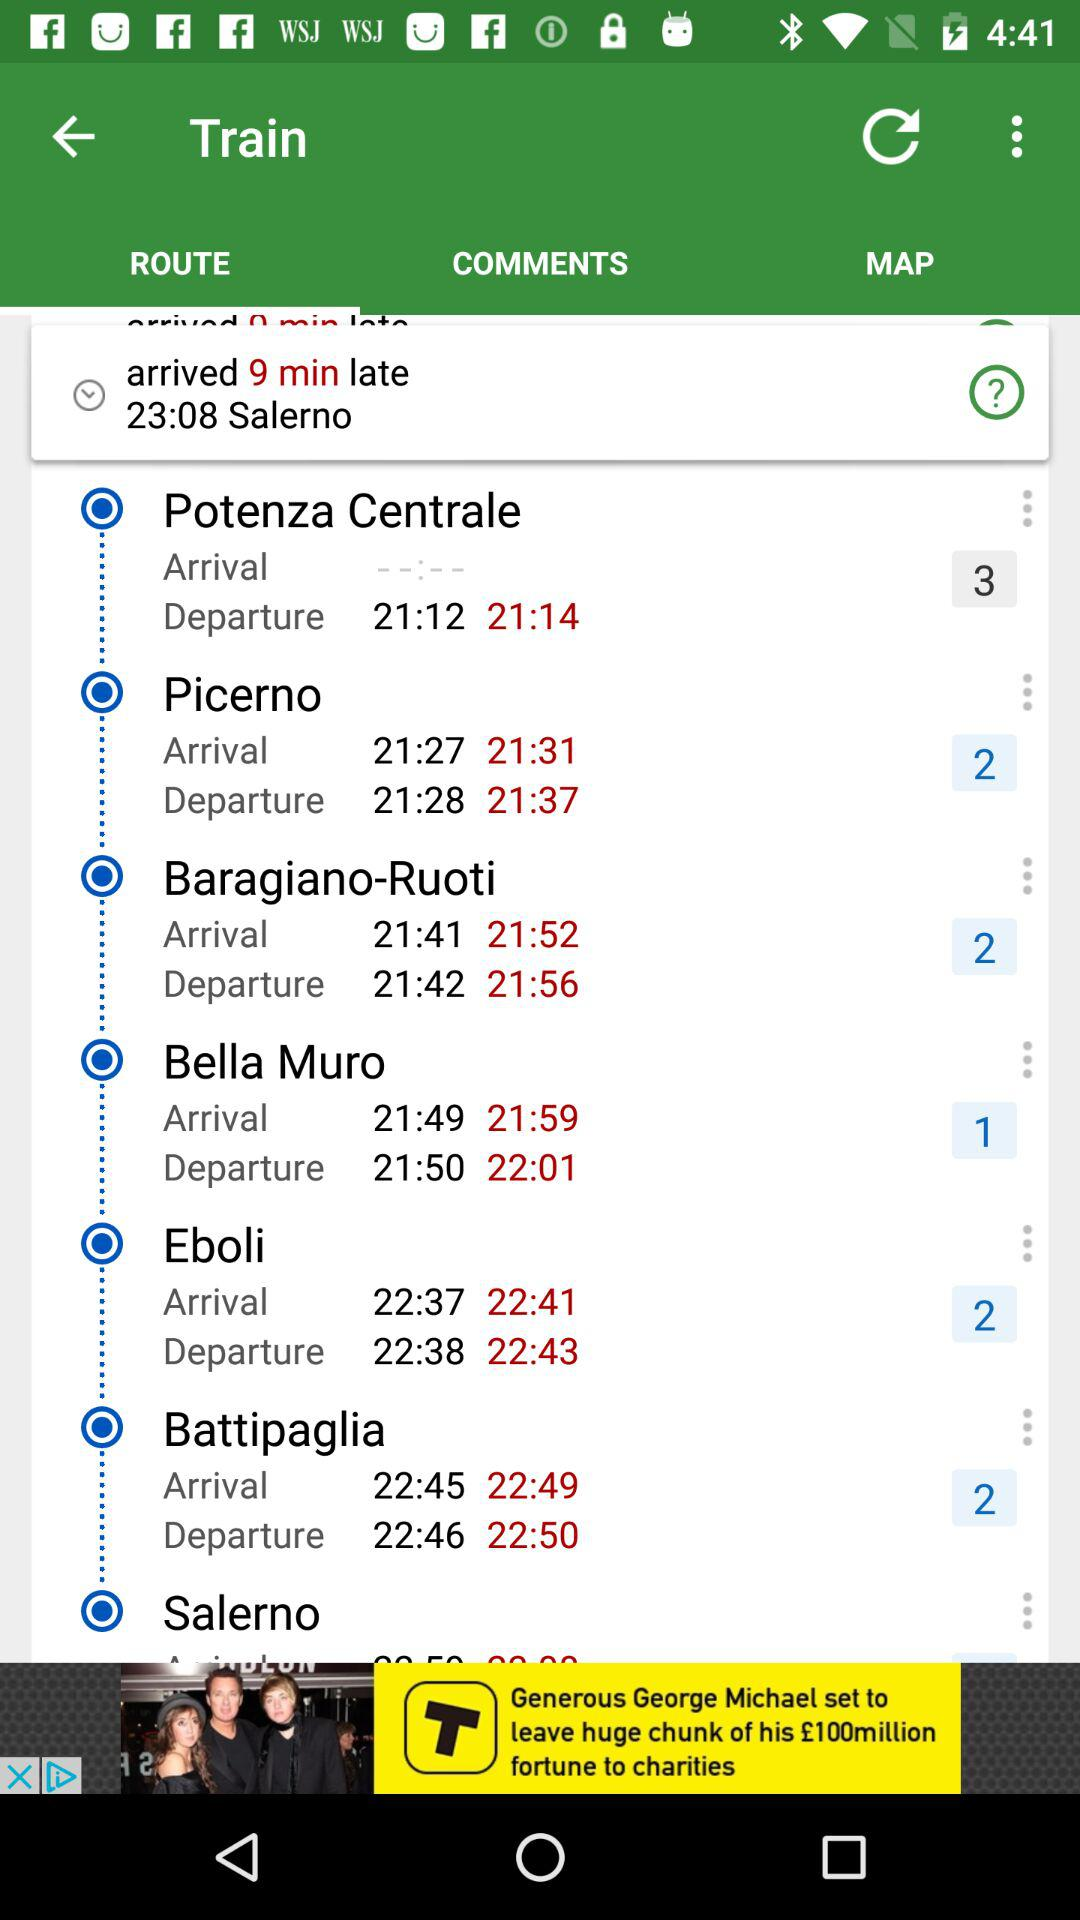Which tab is selected? The selected tab is "ROUTE". 